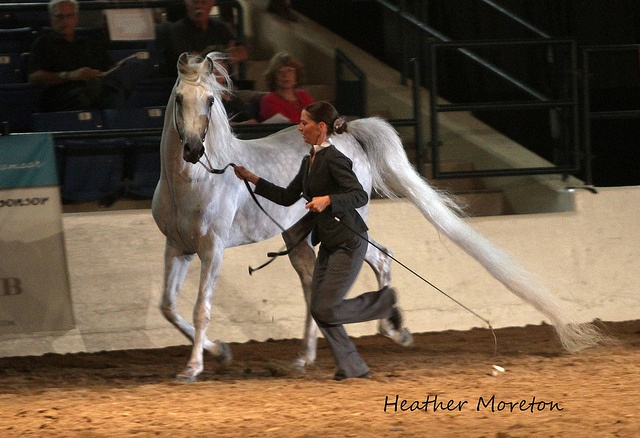Describe the objects in this image and their specific colors. I can see horse in black, darkgray, lightgray, gray, and maroon tones, people in black, gray, and maroon tones, people in black, maroon, and gray tones, people in black, maroon, gray, and darkgray tones, and people in black, maroon, and gray tones in this image. 